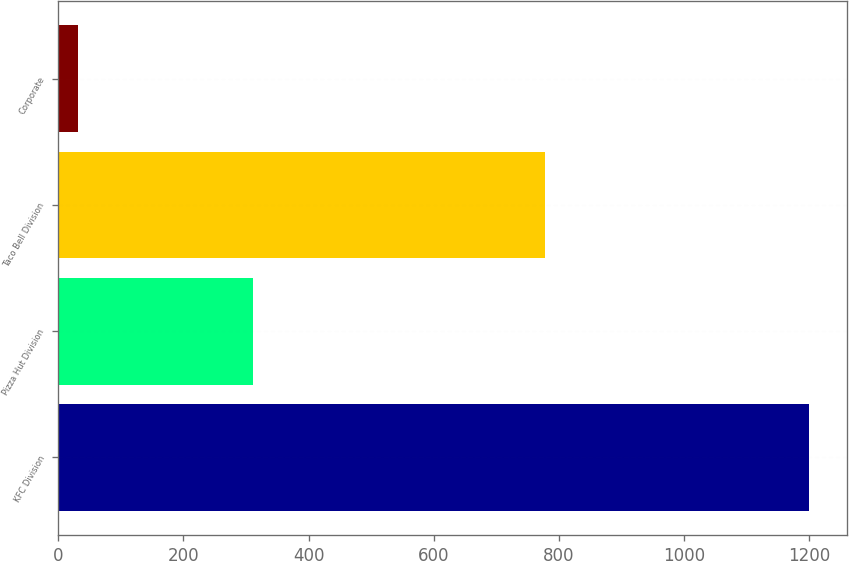<chart> <loc_0><loc_0><loc_500><loc_500><bar_chart><fcel>KFC Division<fcel>Pizza Hut Division<fcel>Taco Bell Division<fcel>Corporate<nl><fcel>1200<fcel>311<fcel>778<fcel>31<nl></chart> 